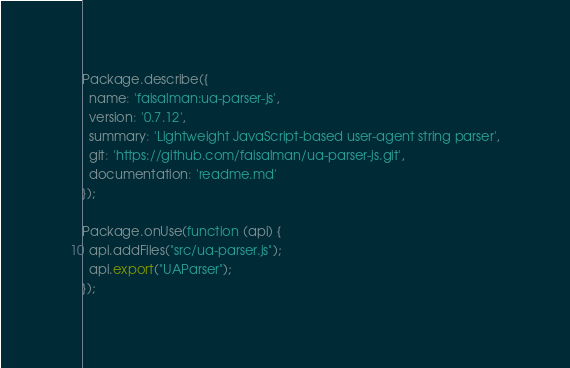Convert code to text. <code><loc_0><loc_0><loc_500><loc_500><_JavaScript_>Package.describe({
  name: 'faisalman:ua-parser-js',
  version: '0.7.12',
  summary: 'Lightweight JavaScript-based user-agent string parser',
  git: 'https://github.com/faisalman/ua-parser-js.git',
  documentation: 'readme.md'
});

Package.onUse(function (api) {
  api.addFiles("src/ua-parser.js");
  api.export("UAParser");
});
</code> 